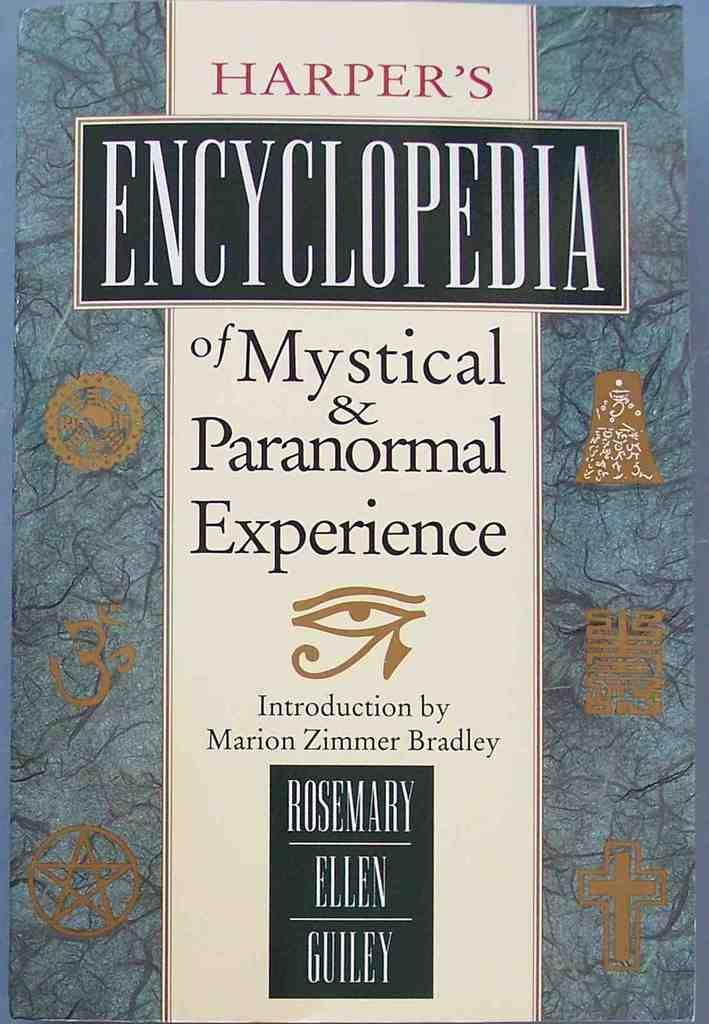Provide a one-sentence caption for the provided image. A book called Harper's Encyclopedia of Mystical & Paranormal Experience. 